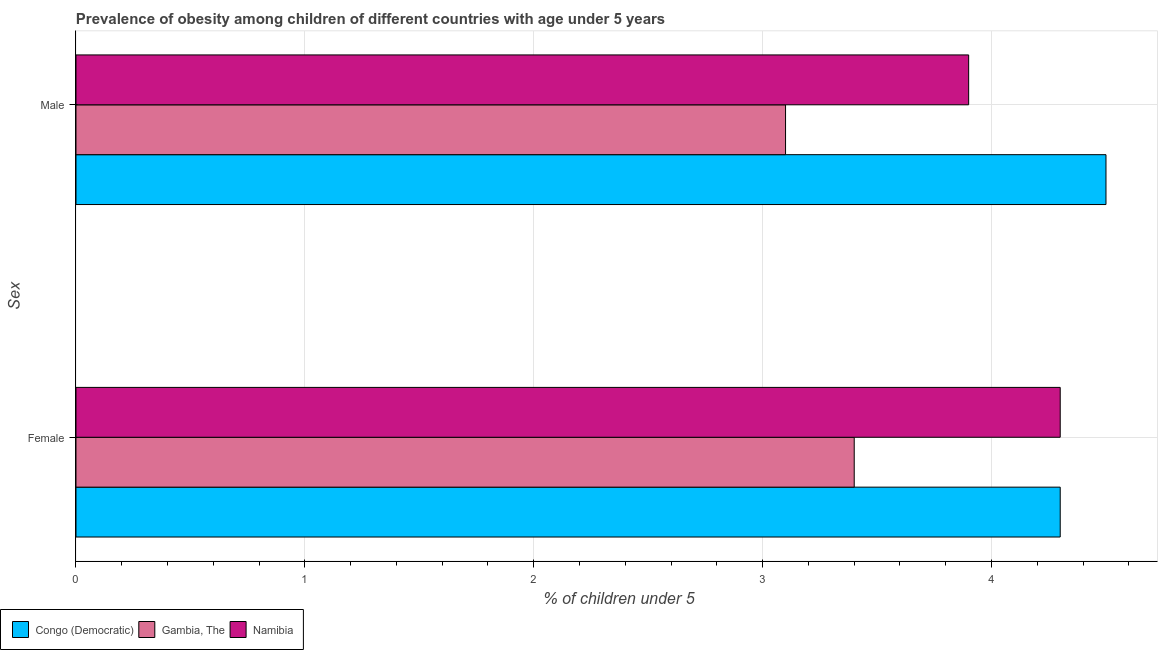How many bars are there on the 2nd tick from the bottom?
Provide a short and direct response. 3. What is the label of the 2nd group of bars from the top?
Offer a very short reply. Female. What is the percentage of obese female children in Namibia?
Offer a terse response. 4.3. Across all countries, what is the maximum percentage of obese female children?
Provide a succinct answer. 4.3. Across all countries, what is the minimum percentage of obese female children?
Your response must be concise. 3.4. In which country was the percentage of obese male children maximum?
Your answer should be compact. Congo (Democratic). In which country was the percentage of obese male children minimum?
Give a very brief answer. Gambia, The. What is the total percentage of obese male children in the graph?
Your answer should be compact. 11.5. What is the difference between the percentage of obese male children in Congo (Democratic) and that in Gambia, The?
Keep it short and to the point. 1.4. What is the difference between the percentage of obese female children in Gambia, The and the percentage of obese male children in Namibia?
Offer a terse response. -0.5. What is the average percentage of obese female children per country?
Keep it short and to the point. 4. What is the difference between the percentage of obese female children and percentage of obese male children in Gambia, The?
Your answer should be compact. 0.3. In how many countries, is the percentage of obese male children greater than 2 %?
Your response must be concise. 3. What is the ratio of the percentage of obese male children in Congo (Democratic) to that in Namibia?
Ensure brevity in your answer.  1.15. What does the 1st bar from the top in Female represents?
Your answer should be very brief. Namibia. What does the 2nd bar from the bottom in Male represents?
Make the answer very short. Gambia, The. How many countries are there in the graph?
Your answer should be compact. 3. Does the graph contain any zero values?
Your answer should be compact. No. Does the graph contain grids?
Offer a terse response. Yes. How are the legend labels stacked?
Offer a very short reply. Horizontal. What is the title of the graph?
Offer a terse response. Prevalence of obesity among children of different countries with age under 5 years. What is the label or title of the X-axis?
Your answer should be compact.  % of children under 5. What is the label or title of the Y-axis?
Keep it short and to the point. Sex. What is the  % of children under 5 of Congo (Democratic) in Female?
Offer a terse response. 4.3. What is the  % of children under 5 of Gambia, The in Female?
Offer a terse response. 3.4. What is the  % of children under 5 in Namibia in Female?
Your response must be concise. 4.3. What is the  % of children under 5 of Gambia, The in Male?
Make the answer very short. 3.1. What is the  % of children under 5 of Namibia in Male?
Offer a very short reply. 3.9. Across all Sex, what is the maximum  % of children under 5 of Gambia, The?
Keep it short and to the point. 3.4. Across all Sex, what is the maximum  % of children under 5 in Namibia?
Provide a succinct answer. 4.3. Across all Sex, what is the minimum  % of children under 5 of Congo (Democratic)?
Offer a terse response. 4.3. Across all Sex, what is the minimum  % of children under 5 in Gambia, The?
Offer a very short reply. 3.1. Across all Sex, what is the minimum  % of children under 5 in Namibia?
Give a very brief answer. 3.9. What is the total  % of children under 5 of Congo (Democratic) in the graph?
Provide a short and direct response. 8.8. What is the total  % of children under 5 in Gambia, The in the graph?
Your response must be concise. 6.5. What is the difference between the  % of children under 5 in Gambia, The in Female and that in Male?
Your answer should be compact. 0.3. What is the difference between the  % of children under 5 in Namibia in Female and that in Male?
Your answer should be very brief. 0.4. What is the average  % of children under 5 in Gambia, The per Sex?
Your answer should be compact. 3.25. What is the difference between the  % of children under 5 of Congo (Democratic) and  % of children under 5 of Gambia, The in Female?
Your answer should be compact. 0.9. What is the ratio of the  % of children under 5 of Congo (Democratic) in Female to that in Male?
Ensure brevity in your answer.  0.96. What is the ratio of the  % of children under 5 of Gambia, The in Female to that in Male?
Your response must be concise. 1.1. What is the ratio of the  % of children under 5 of Namibia in Female to that in Male?
Give a very brief answer. 1.1. What is the difference between the highest and the second highest  % of children under 5 of Gambia, The?
Your response must be concise. 0.3. What is the difference between the highest and the second highest  % of children under 5 of Namibia?
Your answer should be very brief. 0.4. What is the difference between the highest and the lowest  % of children under 5 of Congo (Democratic)?
Your answer should be very brief. 0.2. 